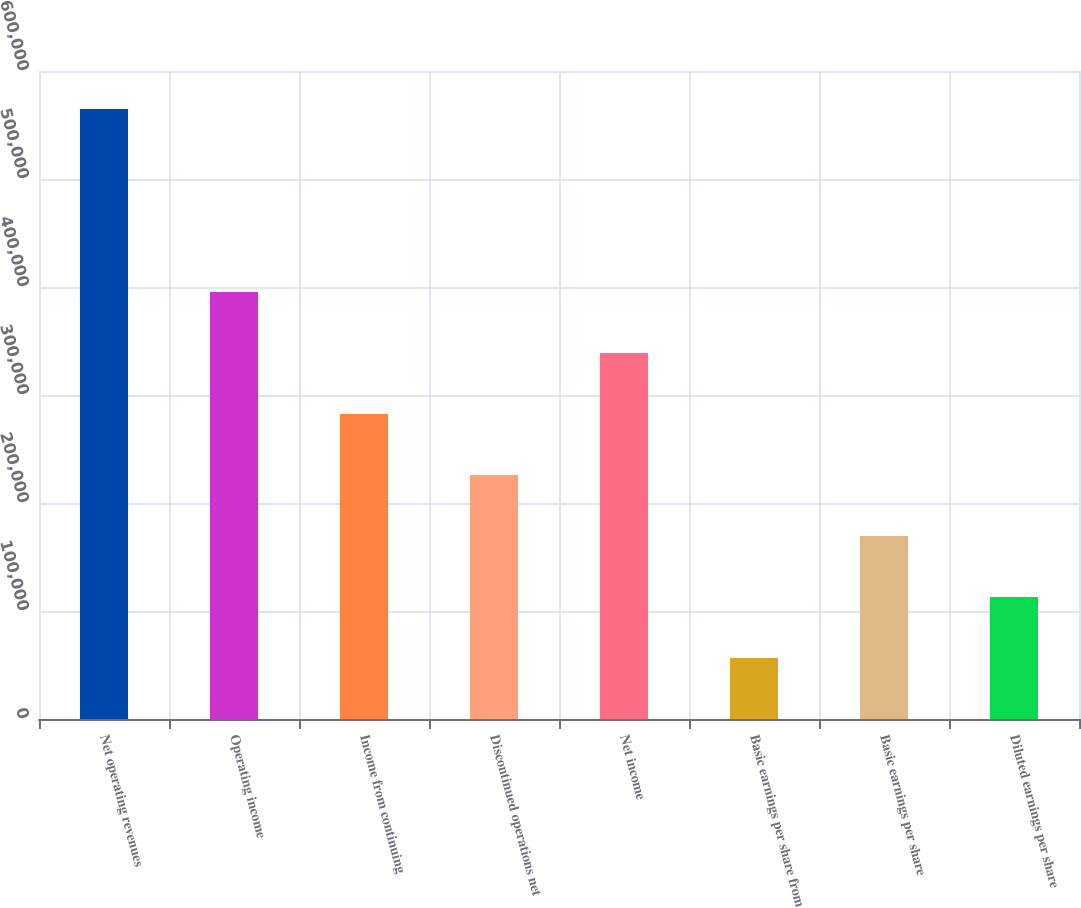Convert chart to OTSL. <chart><loc_0><loc_0><loc_500><loc_500><bar_chart><fcel>Net operating revenues<fcel>Operating income<fcel>Income from continuing<fcel>Discontinued operations net<fcel>Net income<fcel>Basic earnings per share from<fcel>Basic earnings per share<fcel>Diluted earnings per share<nl><fcel>564929<fcel>395450<fcel>282465<fcel>225972<fcel>338958<fcel>56493.4<fcel>169479<fcel>112986<nl></chart> 